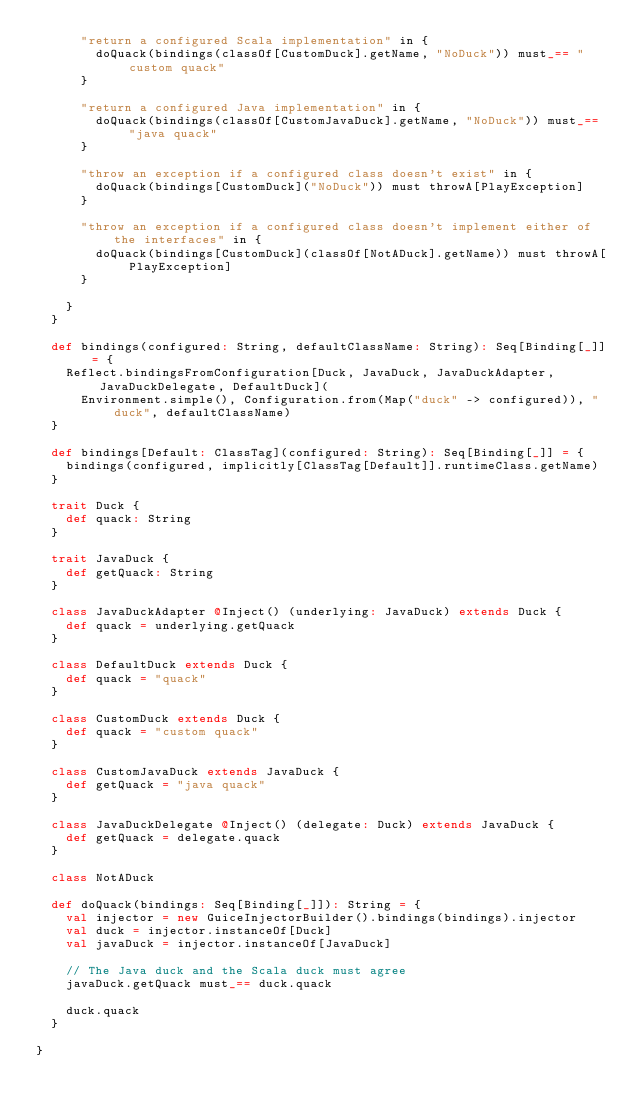<code> <loc_0><loc_0><loc_500><loc_500><_Scala_>      "return a configured Scala implementation" in {
        doQuack(bindings(classOf[CustomDuck].getName, "NoDuck")) must_== "custom quack"
      }

      "return a configured Java implementation" in {
        doQuack(bindings(classOf[CustomJavaDuck].getName, "NoDuck")) must_== "java quack"
      }

      "throw an exception if a configured class doesn't exist" in {
        doQuack(bindings[CustomDuck]("NoDuck")) must throwA[PlayException]
      }

      "throw an exception if a configured class doesn't implement either of the interfaces" in {
        doQuack(bindings[CustomDuck](classOf[NotADuck].getName)) must throwA[PlayException]
      }

    }
  }

  def bindings(configured: String, defaultClassName: String): Seq[Binding[_]] = {
    Reflect.bindingsFromConfiguration[Duck, JavaDuck, JavaDuckAdapter, JavaDuckDelegate, DefaultDuck](
      Environment.simple(), Configuration.from(Map("duck" -> configured)), "duck", defaultClassName)
  }

  def bindings[Default: ClassTag](configured: String): Seq[Binding[_]] = {
    bindings(configured, implicitly[ClassTag[Default]].runtimeClass.getName)
  }

  trait Duck {
    def quack: String
  }

  trait JavaDuck {
    def getQuack: String
  }

  class JavaDuckAdapter @Inject() (underlying: JavaDuck) extends Duck {
    def quack = underlying.getQuack
  }

  class DefaultDuck extends Duck {
    def quack = "quack"
  }

  class CustomDuck extends Duck {
    def quack = "custom quack"
  }

  class CustomJavaDuck extends JavaDuck {
    def getQuack = "java quack"
  }

  class JavaDuckDelegate @Inject() (delegate: Duck) extends JavaDuck {
    def getQuack = delegate.quack
  }

  class NotADuck

  def doQuack(bindings: Seq[Binding[_]]): String = {
    val injector = new GuiceInjectorBuilder().bindings(bindings).injector
    val duck = injector.instanceOf[Duck]
    val javaDuck = injector.instanceOf[JavaDuck]

    // The Java duck and the Scala duck must agree
    javaDuck.getQuack must_== duck.quack

    duck.quack
  }

}
</code> 